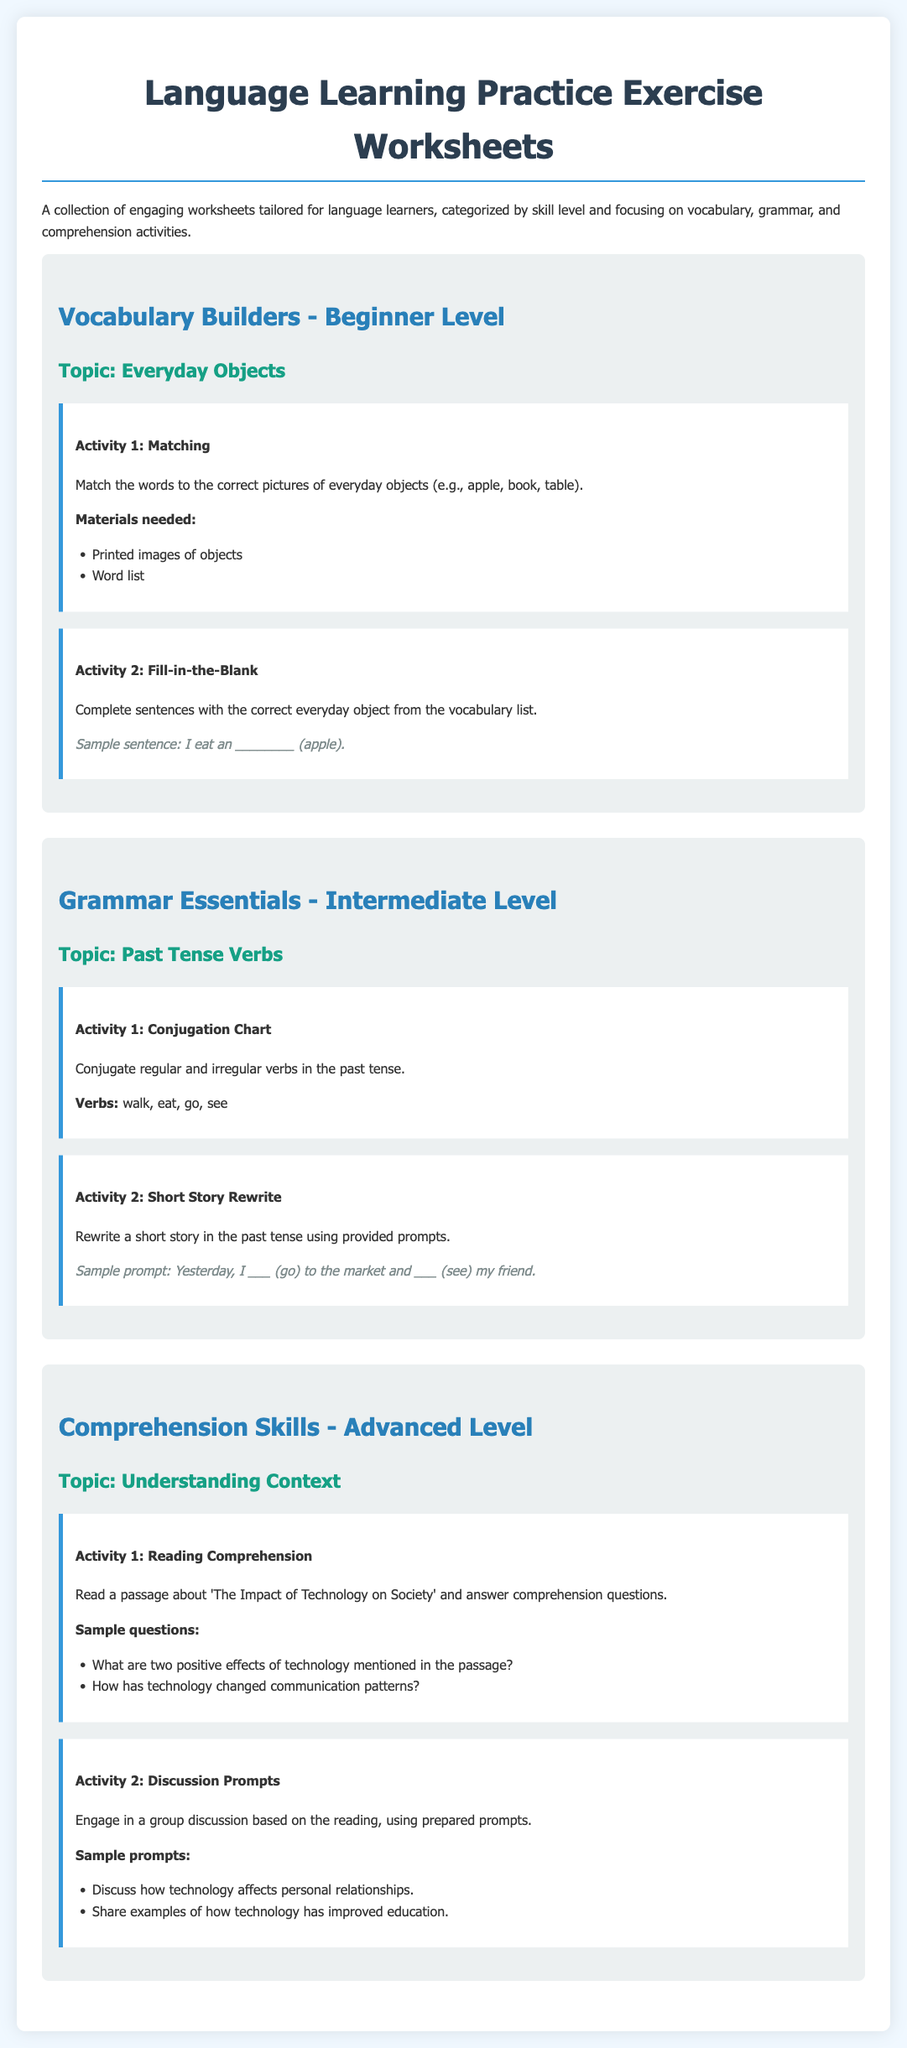What is the title of the document? The title is presented prominently at the top of the document.
Answer: Language Learning Practice Exercise Worksheets What is the first topic covered in the worksheets? The document outlines each worksheet and its corresponding topic; the first one is specified under the beginner level.
Answer: Everyday Objects Name one material needed for the first vocabulary activity. The materials needed are listed under the first activity description.
Answer: Printed images of objects What activity involves rewriting a short story? The second activity under the intermediate level grammar section describes this task.
Answer: Short Story Rewrite What is the focus of the advanced comprehension skills section? The topic is explicitly stated in the heading of the section.
Answer: Understanding Context How many sample questions are provided for the reading comprehension activity? The number of questions can be counted in the list provided for the activity.
Answer: Two What is one of the verbs to be conjugated in the past tense? The list of verbs can be found in the activity prompt for conjugation in the intermediate level.
Answer: walk What color is the background of the document? The background color is specified in the style section of the document's code.
Answer: #f0f8ff What level is the vocabulary builder worksheet designed for? The worksheet is categorized by skill level, clearly stated in the heading.
Answer: Beginner Level 